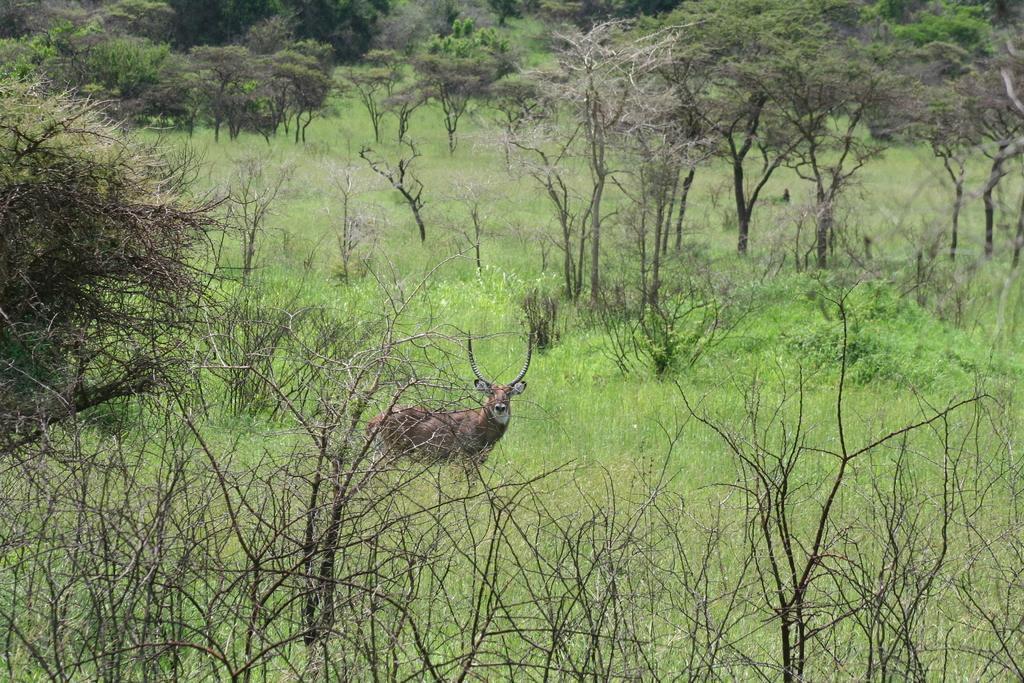Please provide a concise description of this image. The picture is taken in a forest. In the foreground of the picture there are plants and grass. In the center of the picture there is an antelope. In the background there are trees, grass and plants. 